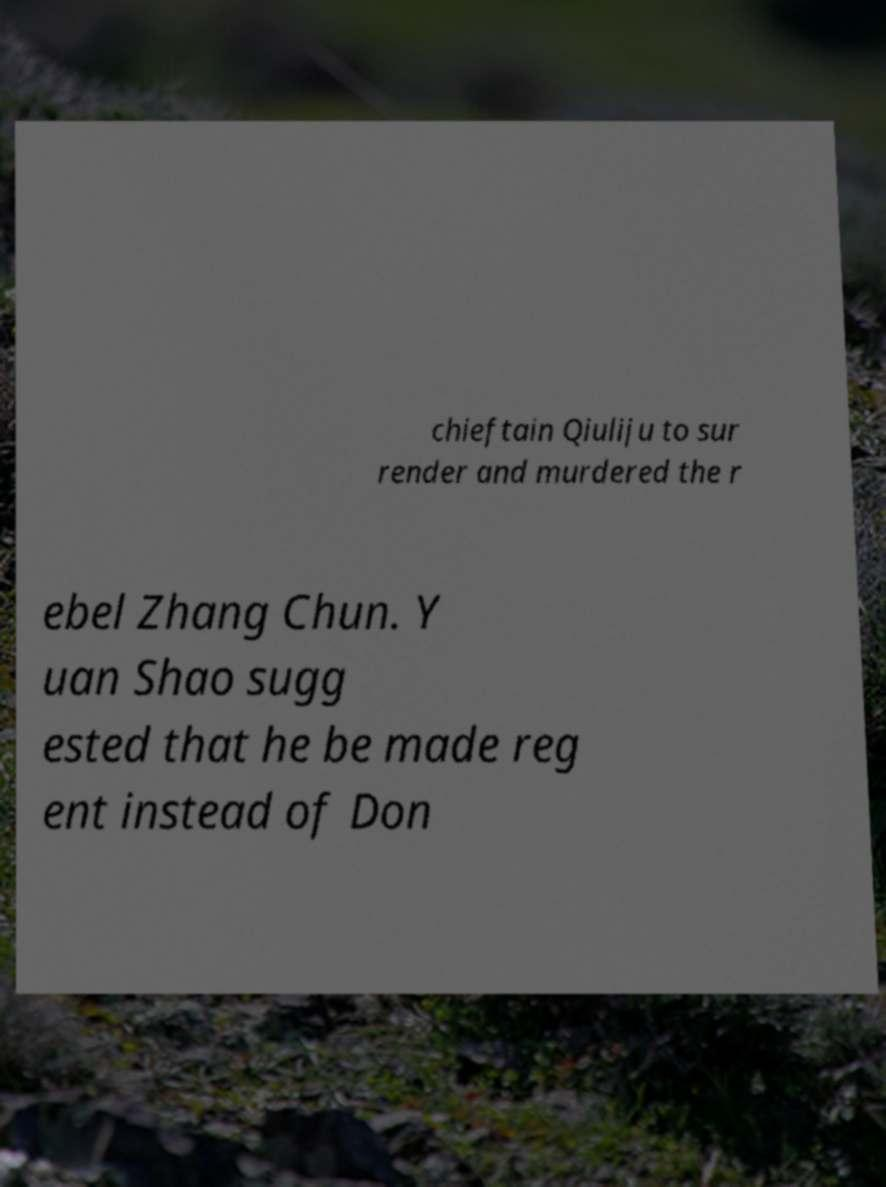Could you extract and type out the text from this image? chieftain Qiuliju to sur render and murdered the r ebel Zhang Chun. Y uan Shao sugg ested that he be made reg ent instead of Don 